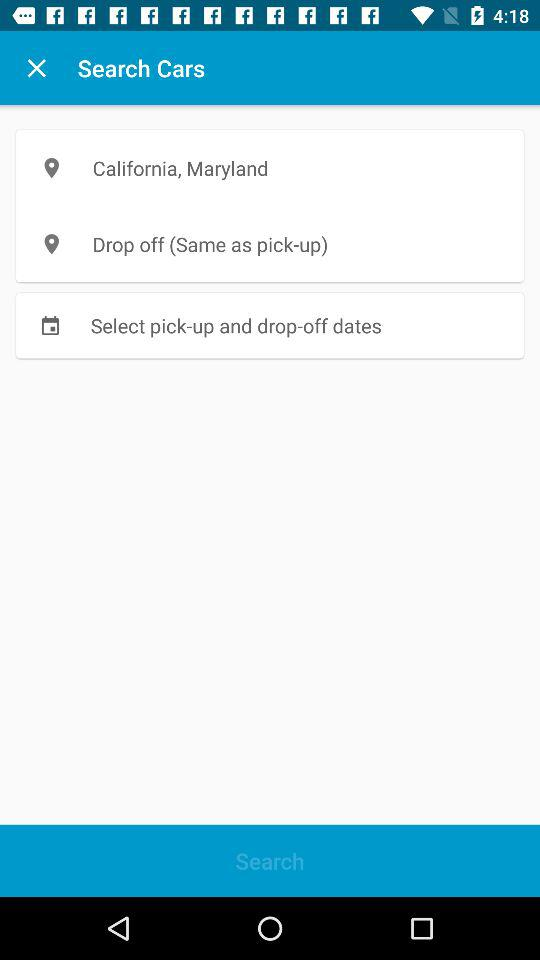What is the location for drop off? The drop-off location is "Same as pick-up". 